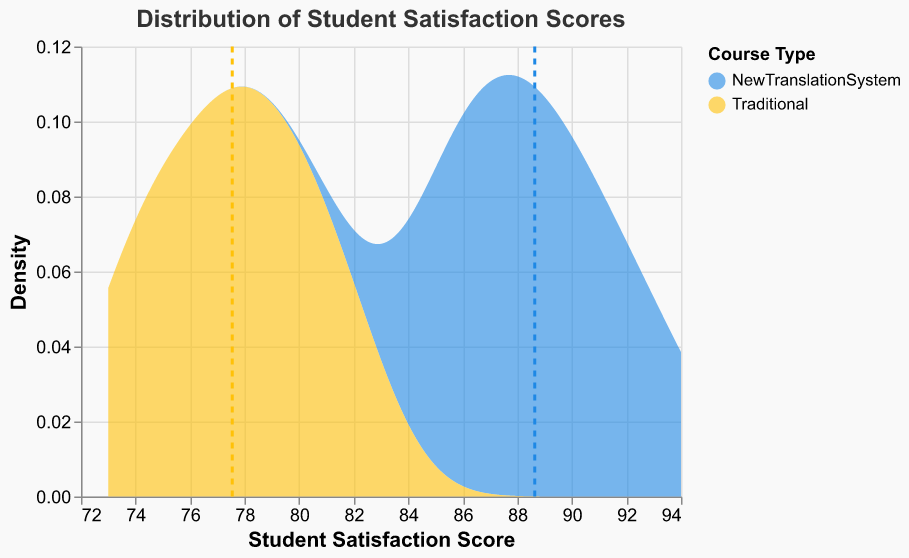What is the title of the figure? The title is displayed at the top of the figure. It summarizes the content of the figure, which is about the distribution of student satisfaction scores.
Answer: Distribution of Student Satisfaction Scores What are the two course types compared in the figure? The two course types are indicated by the colors in the legend. The first course type is presented in blue and the second one in yellow.
Answer: NewTranslationSystem and Traditional Which course type has a higher density at a score of 85? By looking at the y-axis values at the score of 85 on the x-axis, the blue area representing the New Translation System is higher than the yellow area representing the Traditional course.
Answer: NewTranslationSystem What is the approximate mean student satisfaction score for the Traditional course type? The mean score for the Traditional course is represented by the vertical dashed yellow line on the x-axis. It appears to be around 77.
Answer: 77 Which course type shows a wider spread of student satisfaction scores? By examining the width of the area under the curve for each course type, the New Translation System shows a wider spread spanning from about 85 to 94, whereas the Traditional course spans from approximately 73 to 82.
Answer: NewTranslationSystem What's the difference between the mean student satisfaction scores of the two course types? By locating the vertical dashed lines, the mean for New Translation System seems to be around 89 and for Traditional around 77. The difference is 89 - 77.
Answer: 12 In which range is the peak density for the New Translation System? The peak density for the New Translation System can be identified as the highest point of the blue area. This peak occurs approximately between the scores of 88 and 90.
Answer: 88-90 How does the density curve for the Traditional course type shape compared to the New Translation System? The curve of the Traditional course type has a more narrow and taller peak, suggesting less variation, while the curve of the New Translation System is wider and less peaked, indicating greater variation.
Answer: Narrower and taller What is one significant insight you can derive about student satisfaction when comparing the two course types? Comparing the distribution shapes, the higher mean and wider distribution of New Translation System scores indicate that students are generally more satisfied and the satisfaction scores vary more in this course type.
Answer: NewTranslationSystem has higher satisfaction and more variation 